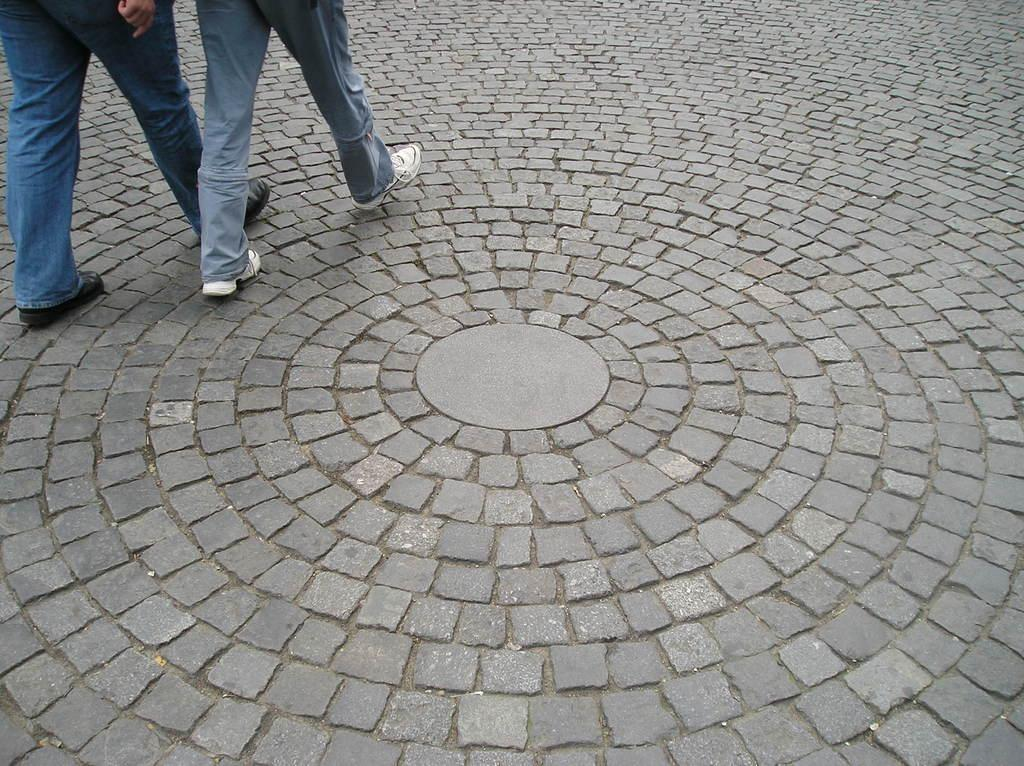How many people are in the image? There are two people in the image. What are the people doing in the image? The people are walking. What is the color of the surface they are walking on? The surface they are walking on is grey in color. What type of fowl can be seen in the image? There is no fowl present in the image. How many hands are visible in the image? The number of hands visible in the image cannot be determined from the provided facts. 